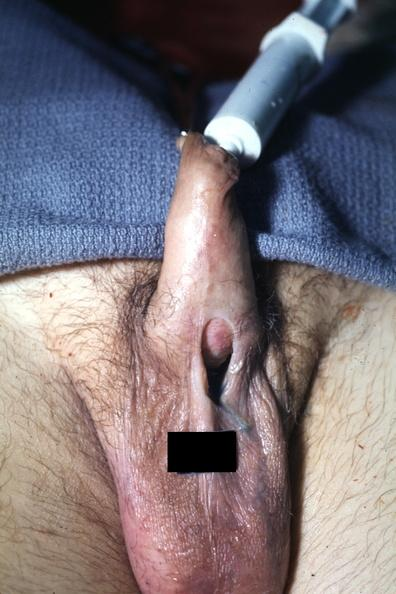s hypospadias present?
Answer the question using a single word or phrase. Yes 